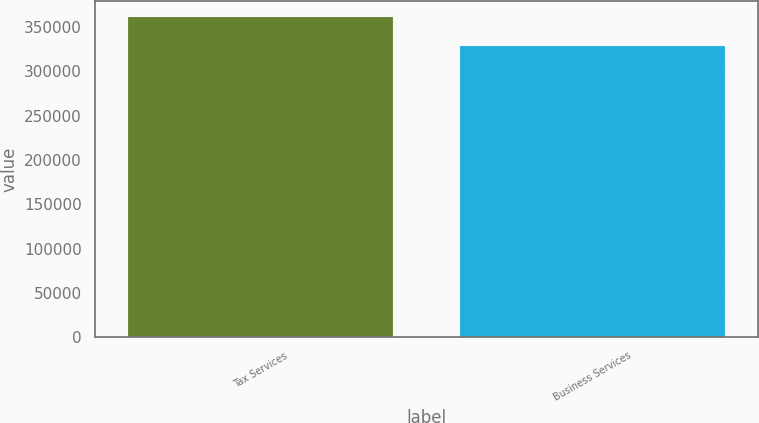<chart> <loc_0><loc_0><loc_500><loc_500><bar_chart><fcel>Tax Services<fcel>Business Services<nl><fcel>360781<fcel>328745<nl></chart> 